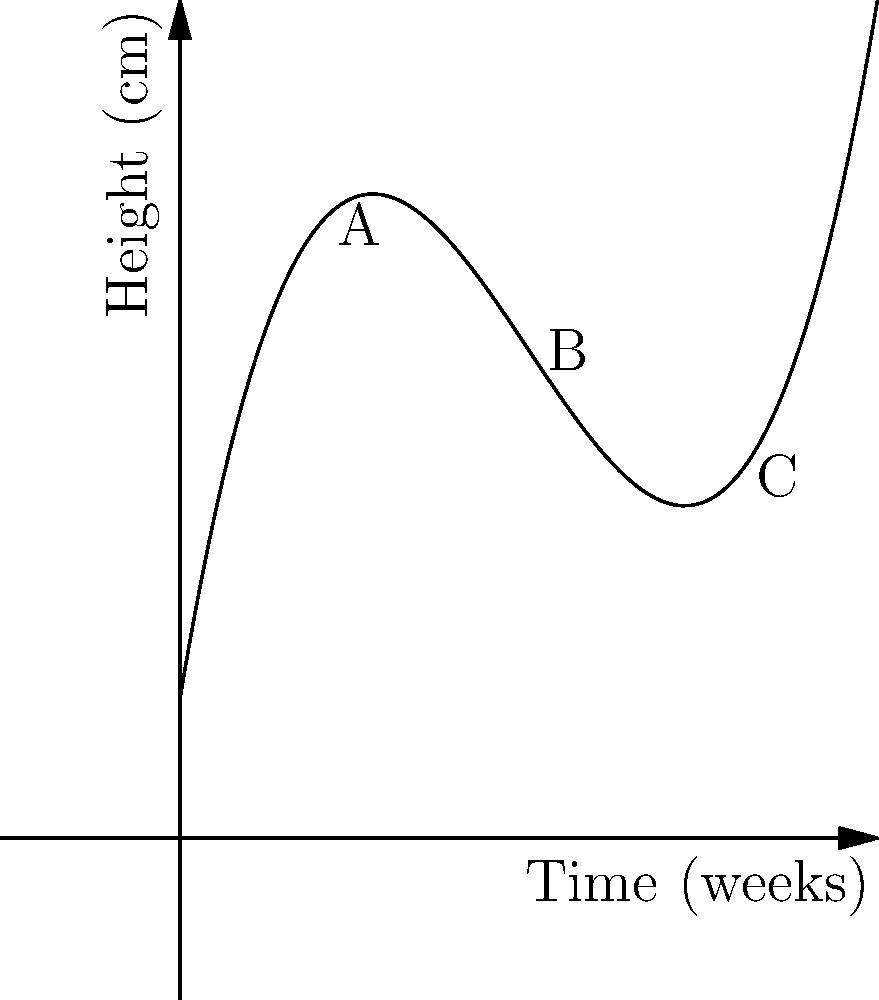The cubic polynomial graph represents the growth of a medicinal herb over time. If the function is given by $h(t) = 0.1t^3 - 1.5t^2 + 6t + 2$, where $h$ is the height in centimeters and $t$ is the time in weeks, what is the average growth rate (in cm/week) of the herb between points B and C? To find the average growth rate between points B and C, we need to:

1. Calculate the heights at points B and C:
   Point B (t = 5): $h(5) = 0.1(5^3) - 1.5(5^2) + 6(5) + 2 = 12.5$ cm
   Point C (t = 8): $h(8) = 0.1(8^3) - 1.5(8^2) + 6(8) + 2 = 26$ cm

2. Calculate the change in height:
   $\Delta h = h(8) - h(5) = 26 - 12.5 = 13.5$ cm

3. Calculate the change in time:
   $\Delta t = 8 - 5 = 3$ weeks

4. Calculate the average growth rate:
   Average growth rate = $\frac{\Delta h}{\Delta t} = \frac{13.5 \text{ cm}}{3 \text{ weeks}} = 4.5$ cm/week
Answer: 4.5 cm/week 